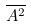Convert formula to latex. <formula><loc_0><loc_0><loc_500><loc_500>\overline { A ^ { 2 } }</formula> 